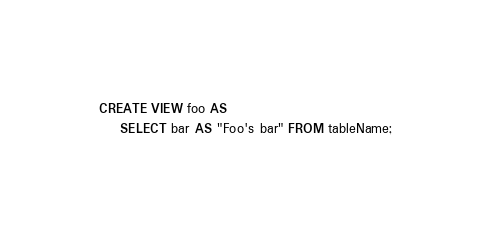Convert code to text. <code><loc_0><loc_0><loc_500><loc_500><_SQL_>
CREATE VIEW foo AS
	SELECT bar AS "Foo's bar" FROM tableName;
</code> 